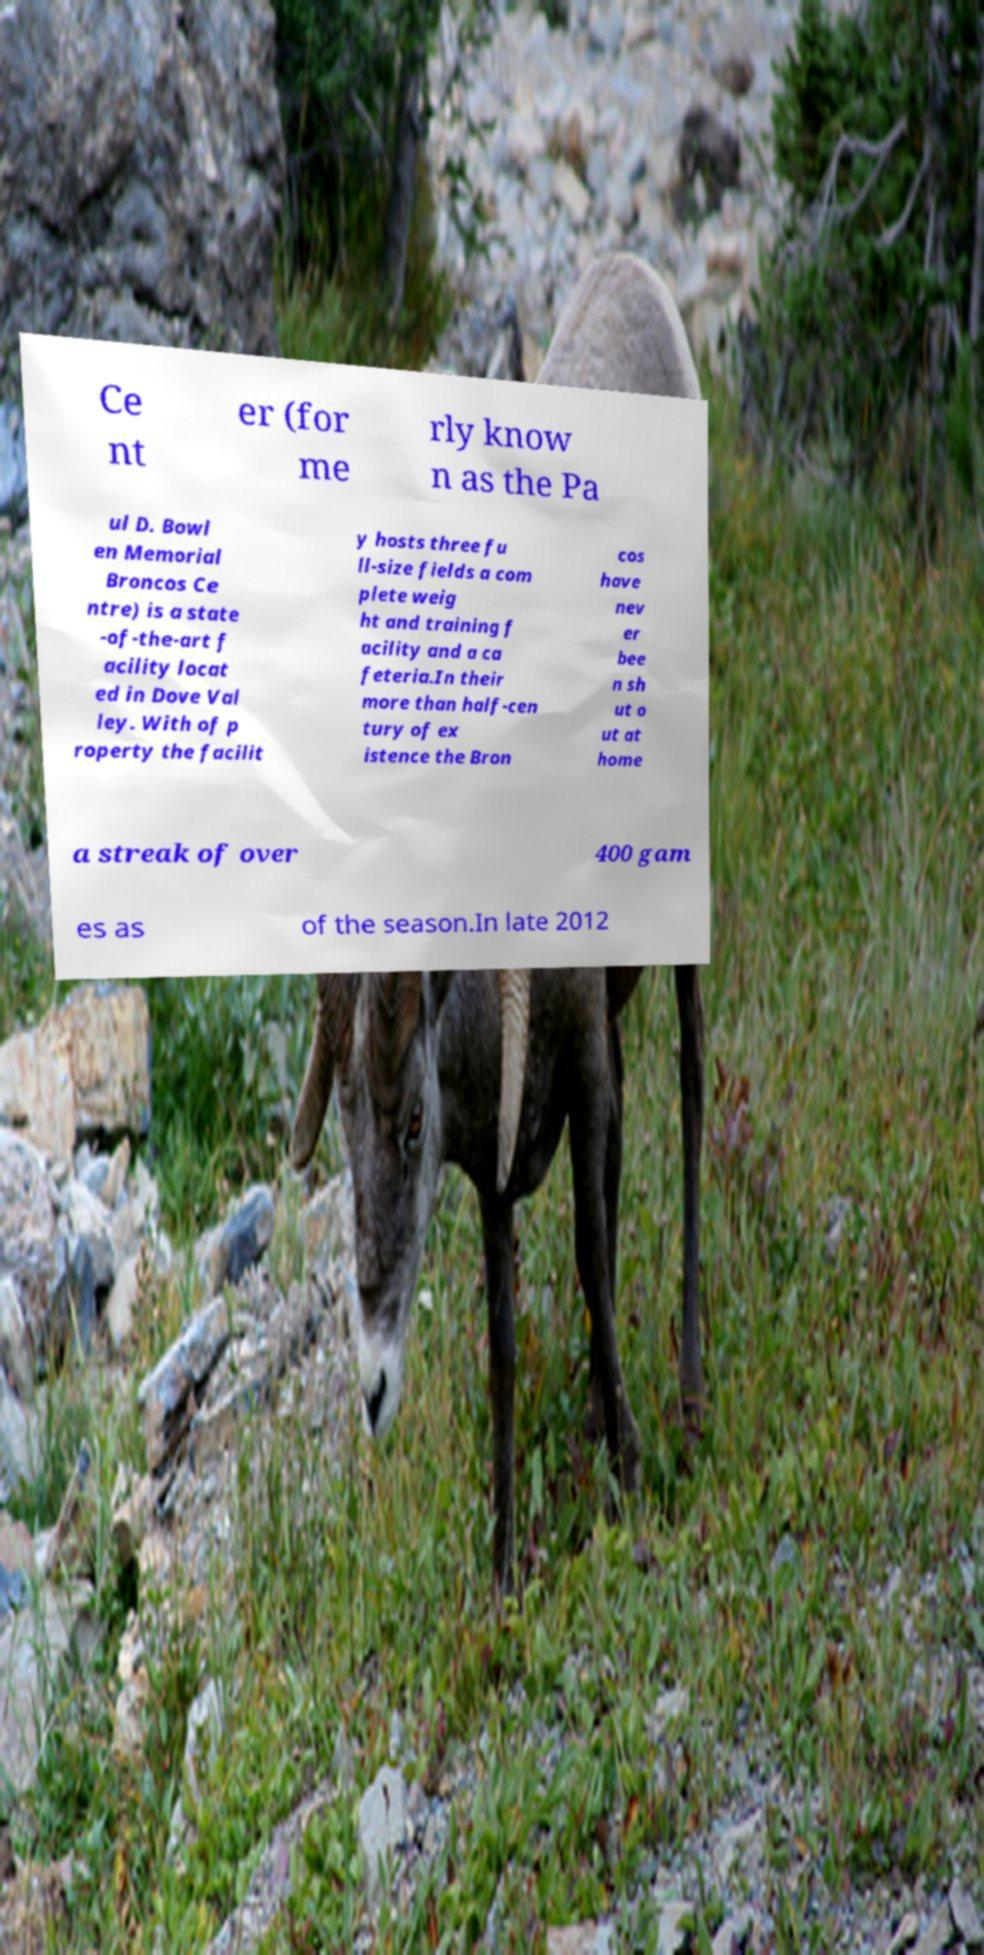What messages or text are displayed in this image? I need them in a readable, typed format. Ce nt er (for me rly know n as the Pa ul D. Bowl en Memorial Broncos Ce ntre) is a state -of-the-art f acility locat ed in Dove Val ley. With of p roperty the facilit y hosts three fu ll-size fields a com plete weig ht and training f acility and a ca feteria.In their more than half-cen tury of ex istence the Bron cos have nev er bee n sh ut o ut at home a streak of over 400 gam es as of the season.In late 2012 